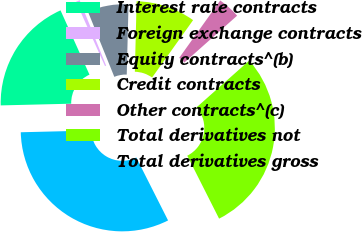Convert chart to OTSL. <chart><loc_0><loc_0><loc_500><loc_500><pie_chart><fcel>Interest rate contracts<fcel>Foreign exchange contracts<fcel>Equity contracts^(b)<fcel>Credit contracts<fcel>Other contracts^(c)<fcel>Total derivatives not<fcel>Total derivatives gross<nl><fcel>18.65%<fcel>0.62%<fcel>6.52%<fcel>9.47%<fcel>3.57%<fcel>29.11%<fcel>32.06%<nl></chart> 